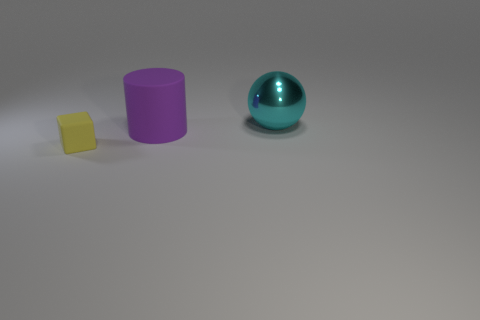There is a object that is in front of the rubber object that is on the right side of the yellow thing; how big is it?
Your response must be concise. Small. Is there any other thing that has the same size as the yellow rubber cube?
Give a very brief answer. No. Is the shape of the matte object behind the tiny thing the same as the thing that is in front of the cylinder?
Give a very brief answer. No. Are there more cyan metal spheres than things?
Offer a terse response. No. What is the size of the purple matte thing?
Offer a very short reply. Large. What number of other things are the same color as the tiny object?
Ensure brevity in your answer.  0. Does the large object to the left of the cyan shiny object have the same material as the cyan object?
Offer a very short reply. No. Are there fewer large rubber things in front of the tiny yellow matte cube than large cyan things that are behind the purple matte cylinder?
Make the answer very short. Yes. What number of other objects are there of the same material as the block?
Your answer should be very brief. 1. There is a purple cylinder that is the same size as the cyan object; what is its material?
Your response must be concise. Rubber. 